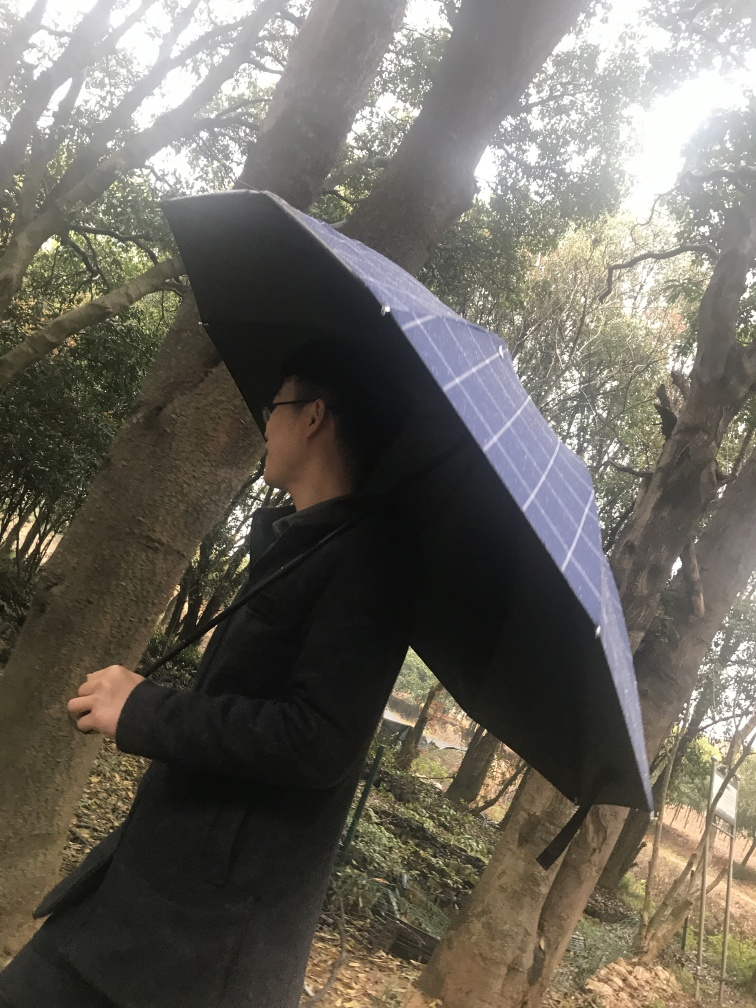Is the umbrella in the photo being used for rain protection or as a sunshade? The person is holding an umbrella, and considering the lack of sunlight and the overall cloudy ambiance, it's more likely being used for rain protection rather than as a sunshade. 